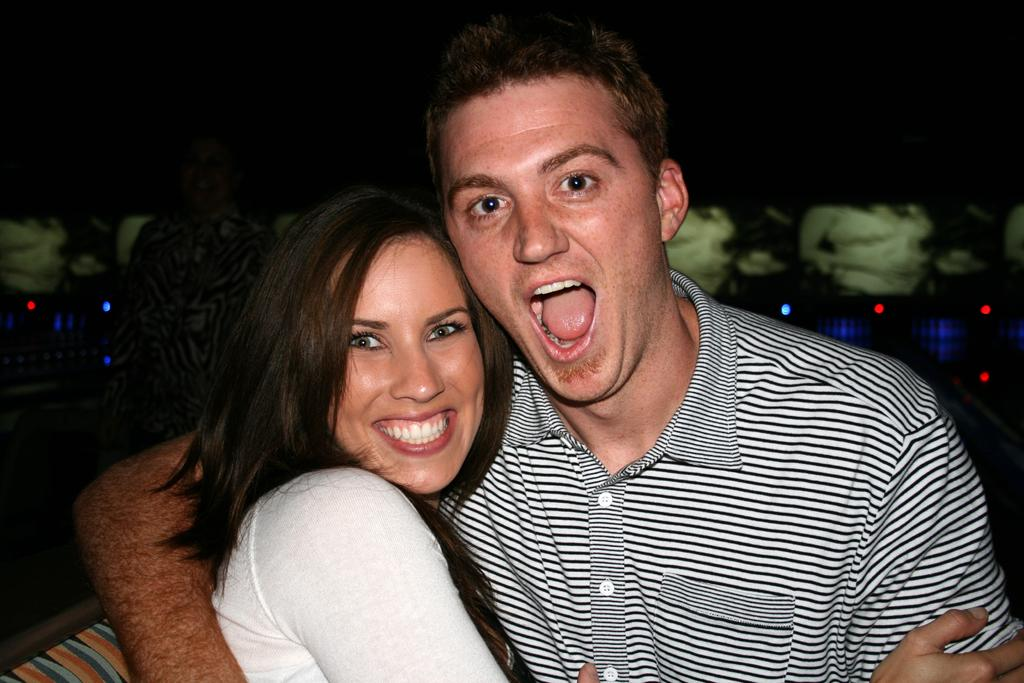How many people are present in the image? There are two people, a man and a woman, present in the image. What can be seen in the background of the image? There are lights visible in the background of the image. What type of wren can be seen in the image? There is no wren present in the image; it features a man and a woman. How many family members are visible in the image? The image does not show any family members, only a man and a woman. 